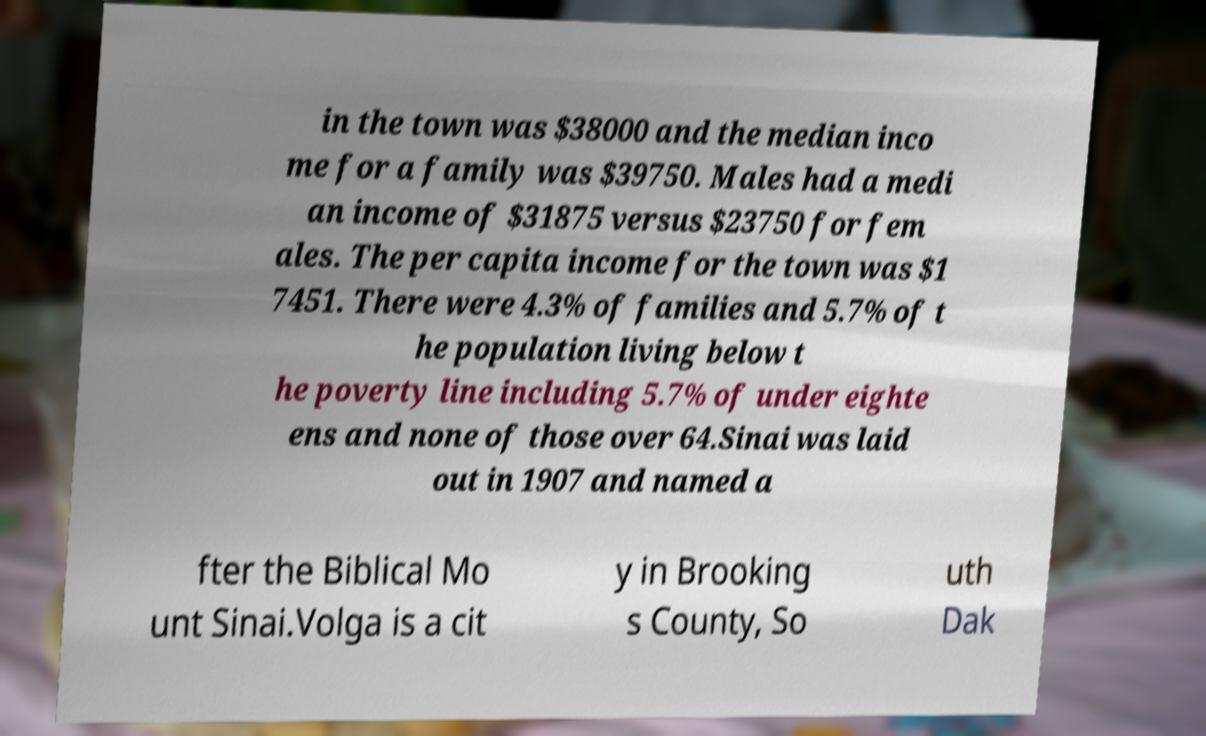There's text embedded in this image that I need extracted. Can you transcribe it verbatim? in the town was $38000 and the median inco me for a family was $39750. Males had a medi an income of $31875 versus $23750 for fem ales. The per capita income for the town was $1 7451. There were 4.3% of families and 5.7% of t he population living below t he poverty line including 5.7% of under eighte ens and none of those over 64.Sinai was laid out in 1907 and named a fter the Biblical Mo unt Sinai.Volga is a cit y in Brooking s County, So uth Dak 